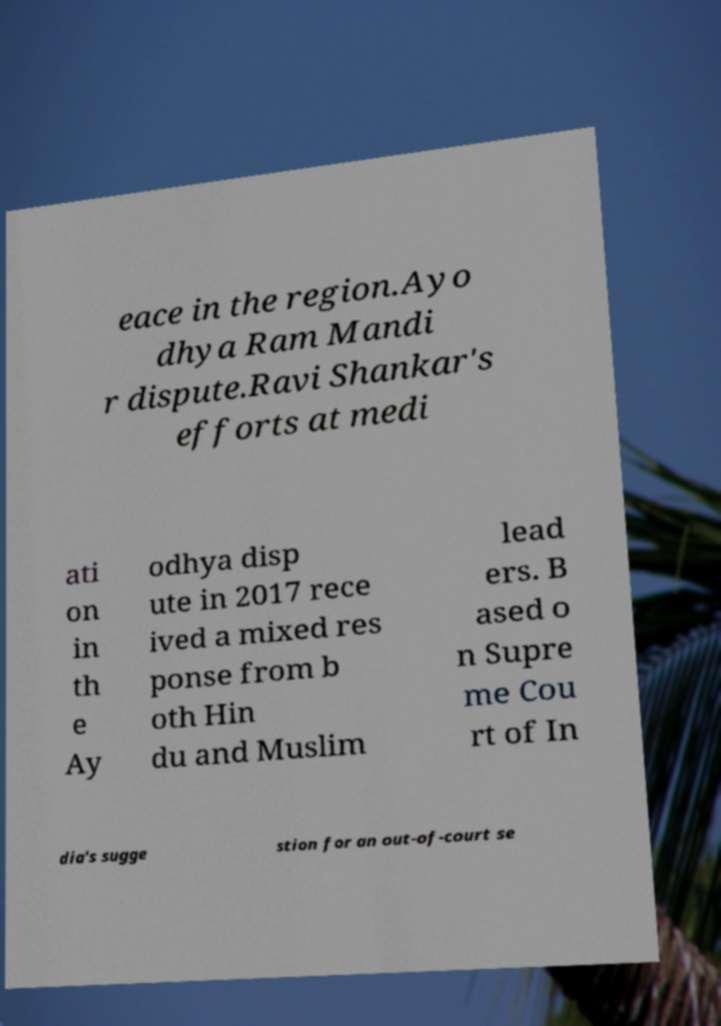I need the written content from this picture converted into text. Can you do that? eace in the region.Ayo dhya Ram Mandi r dispute.Ravi Shankar's efforts at medi ati on in th e Ay odhya disp ute in 2017 rece ived a mixed res ponse from b oth Hin du and Muslim lead ers. B ased o n Supre me Cou rt of In dia's sugge stion for an out-of-court se 